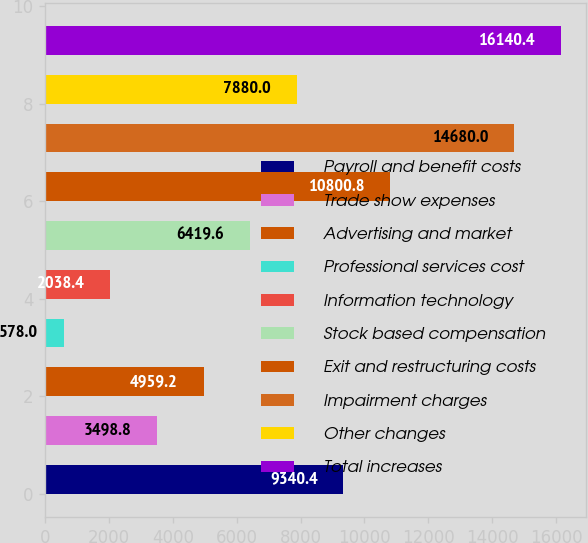<chart> <loc_0><loc_0><loc_500><loc_500><bar_chart><fcel>Payroll and benefit costs<fcel>Trade show expenses<fcel>Advertising and market<fcel>Professional services cost<fcel>Information technology<fcel>Stock based compensation<fcel>Exit and restructuring costs<fcel>Impairment charges<fcel>Other changes<fcel>Total increases<nl><fcel>9340.4<fcel>3498.8<fcel>4959.2<fcel>578<fcel>2038.4<fcel>6419.6<fcel>10800.8<fcel>14680<fcel>7880<fcel>16140.4<nl></chart> 